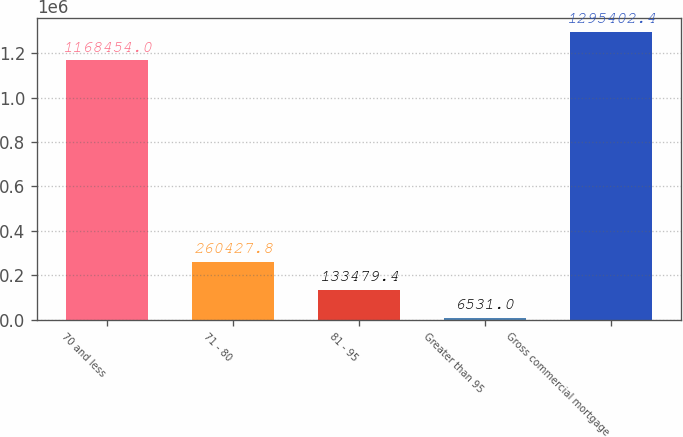Convert chart. <chart><loc_0><loc_0><loc_500><loc_500><bar_chart><fcel>70 and less<fcel>71 - 80<fcel>81 - 95<fcel>Greater than 95<fcel>Gross commercial mortgage<nl><fcel>1.16845e+06<fcel>260428<fcel>133479<fcel>6531<fcel>1.2954e+06<nl></chart> 